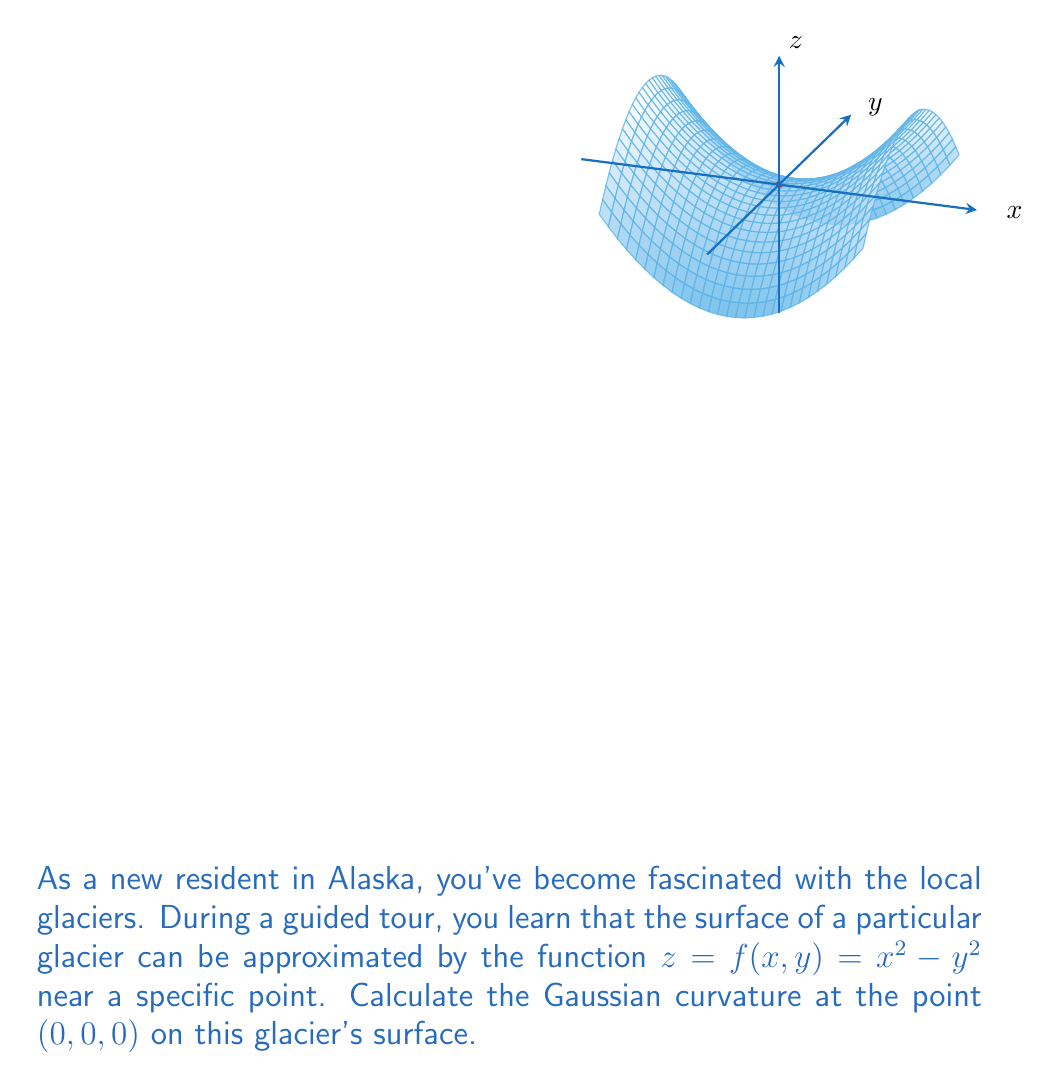Can you answer this question? To find the Gaussian curvature at (0,0,0), we'll follow these steps:

1) The Gaussian curvature K is given by:
   $$K = \frac{f_{xx}f_{yy} - f_{xy}^2}{(1 + f_x^2 + f_y^2)^2}$$
   where subscripts denote partial derivatives.

2) Calculate the partial derivatives:
   $f_x = 2x$
   $f_y = -2y$
   $f_{xx} = 2$
   $f_{yy} = -2$
   $f_{xy} = 0$

3) Evaluate these at the point (0,0,0):
   $f_x(0,0) = 0$
   $f_y(0,0) = 0$
   $f_{xx}(0,0) = 2$
   $f_{yy}(0,0) = -2$
   $f_{xy}(0,0) = 0$

4) Substitute into the Gaussian curvature formula:
   $$K = \frac{(2)(-2) - (0)^2}{(1 + 0^2 + 0^2)^2} = \frac{-4}{1} = -4$$

Therefore, the Gaussian curvature at (0,0,0) is -4.
Answer: $-4$ 